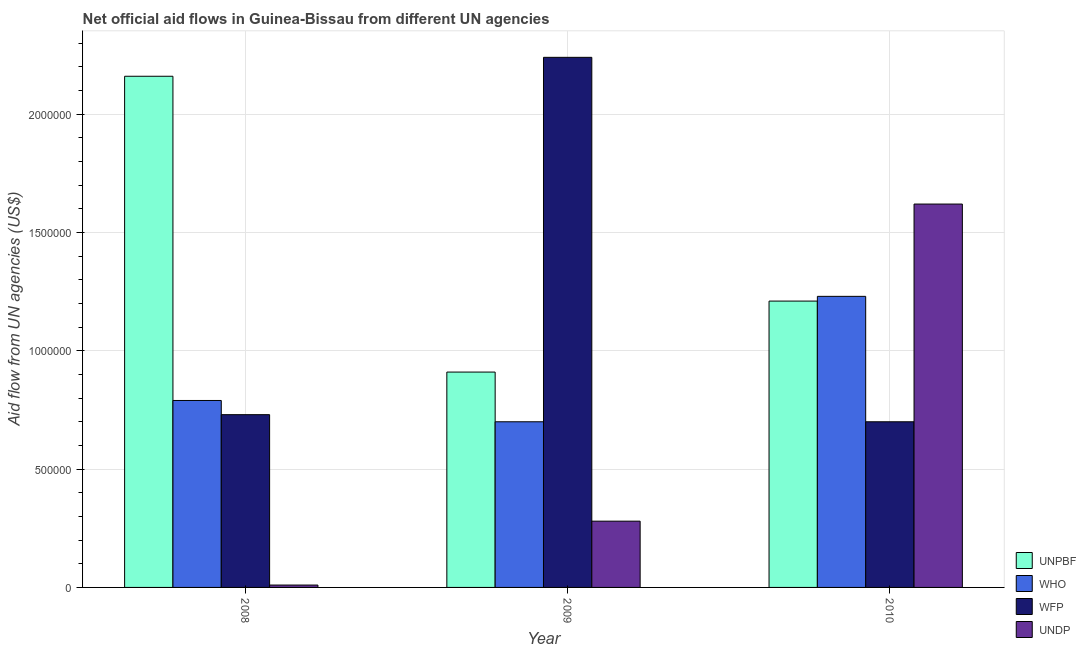How many groups of bars are there?
Offer a very short reply. 3. Are the number of bars per tick equal to the number of legend labels?
Give a very brief answer. Yes. What is the amount of aid given by unpbf in 2008?
Provide a succinct answer. 2.16e+06. Across all years, what is the maximum amount of aid given by wfp?
Ensure brevity in your answer.  2.24e+06. Across all years, what is the minimum amount of aid given by unpbf?
Make the answer very short. 9.10e+05. What is the total amount of aid given by undp in the graph?
Offer a terse response. 1.91e+06. What is the difference between the amount of aid given by wfp in 2008 and that in 2010?
Keep it short and to the point. 3.00e+04. What is the difference between the amount of aid given by undp in 2008 and the amount of aid given by wfp in 2010?
Ensure brevity in your answer.  -1.61e+06. What is the average amount of aid given by unpbf per year?
Ensure brevity in your answer.  1.43e+06. What is the ratio of the amount of aid given by undp in 2008 to that in 2009?
Provide a succinct answer. 0.04. What is the difference between the highest and the second highest amount of aid given by wfp?
Your answer should be very brief. 1.51e+06. What is the difference between the highest and the lowest amount of aid given by wfp?
Offer a very short reply. 1.54e+06. Is it the case that in every year, the sum of the amount of aid given by wfp and amount of aid given by unpbf is greater than the sum of amount of aid given by undp and amount of aid given by who?
Ensure brevity in your answer.  No. What does the 2nd bar from the left in 2009 represents?
Ensure brevity in your answer.  WHO. What does the 2nd bar from the right in 2010 represents?
Offer a very short reply. WFP. Is it the case that in every year, the sum of the amount of aid given by unpbf and amount of aid given by who is greater than the amount of aid given by wfp?
Your response must be concise. No. How many bars are there?
Your response must be concise. 12. How many years are there in the graph?
Your response must be concise. 3. What is the difference between two consecutive major ticks on the Y-axis?
Your answer should be compact. 5.00e+05. Are the values on the major ticks of Y-axis written in scientific E-notation?
Keep it short and to the point. No. Where does the legend appear in the graph?
Provide a succinct answer. Bottom right. How many legend labels are there?
Keep it short and to the point. 4. How are the legend labels stacked?
Offer a terse response. Vertical. What is the title of the graph?
Ensure brevity in your answer.  Net official aid flows in Guinea-Bissau from different UN agencies. What is the label or title of the Y-axis?
Make the answer very short. Aid flow from UN agencies (US$). What is the Aid flow from UN agencies (US$) of UNPBF in 2008?
Your answer should be very brief. 2.16e+06. What is the Aid flow from UN agencies (US$) of WHO in 2008?
Offer a very short reply. 7.90e+05. What is the Aid flow from UN agencies (US$) of WFP in 2008?
Provide a short and direct response. 7.30e+05. What is the Aid flow from UN agencies (US$) in UNDP in 2008?
Offer a terse response. 10000. What is the Aid flow from UN agencies (US$) of UNPBF in 2009?
Ensure brevity in your answer.  9.10e+05. What is the Aid flow from UN agencies (US$) of WHO in 2009?
Give a very brief answer. 7.00e+05. What is the Aid flow from UN agencies (US$) in WFP in 2009?
Provide a short and direct response. 2.24e+06. What is the Aid flow from UN agencies (US$) of UNPBF in 2010?
Your answer should be very brief. 1.21e+06. What is the Aid flow from UN agencies (US$) of WHO in 2010?
Offer a terse response. 1.23e+06. What is the Aid flow from UN agencies (US$) in WFP in 2010?
Give a very brief answer. 7.00e+05. What is the Aid flow from UN agencies (US$) in UNDP in 2010?
Your answer should be very brief. 1.62e+06. Across all years, what is the maximum Aid flow from UN agencies (US$) in UNPBF?
Keep it short and to the point. 2.16e+06. Across all years, what is the maximum Aid flow from UN agencies (US$) of WHO?
Your answer should be very brief. 1.23e+06. Across all years, what is the maximum Aid flow from UN agencies (US$) in WFP?
Provide a short and direct response. 2.24e+06. Across all years, what is the maximum Aid flow from UN agencies (US$) of UNDP?
Ensure brevity in your answer.  1.62e+06. Across all years, what is the minimum Aid flow from UN agencies (US$) in UNPBF?
Provide a succinct answer. 9.10e+05. Across all years, what is the minimum Aid flow from UN agencies (US$) of UNDP?
Provide a succinct answer. 10000. What is the total Aid flow from UN agencies (US$) of UNPBF in the graph?
Make the answer very short. 4.28e+06. What is the total Aid flow from UN agencies (US$) in WHO in the graph?
Offer a very short reply. 2.72e+06. What is the total Aid flow from UN agencies (US$) of WFP in the graph?
Your answer should be very brief. 3.67e+06. What is the total Aid flow from UN agencies (US$) in UNDP in the graph?
Your answer should be compact. 1.91e+06. What is the difference between the Aid flow from UN agencies (US$) of UNPBF in 2008 and that in 2009?
Ensure brevity in your answer.  1.25e+06. What is the difference between the Aid flow from UN agencies (US$) of WHO in 2008 and that in 2009?
Your answer should be compact. 9.00e+04. What is the difference between the Aid flow from UN agencies (US$) in WFP in 2008 and that in 2009?
Your answer should be compact. -1.51e+06. What is the difference between the Aid flow from UN agencies (US$) in UNPBF in 2008 and that in 2010?
Make the answer very short. 9.50e+05. What is the difference between the Aid flow from UN agencies (US$) of WHO in 2008 and that in 2010?
Keep it short and to the point. -4.40e+05. What is the difference between the Aid flow from UN agencies (US$) of UNDP in 2008 and that in 2010?
Your answer should be very brief. -1.61e+06. What is the difference between the Aid flow from UN agencies (US$) in WHO in 2009 and that in 2010?
Your response must be concise. -5.30e+05. What is the difference between the Aid flow from UN agencies (US$) in WFP in 2009 and that in 2010?
Your response must be concise. 1.54e+06. What is the difference between the Aid flow from UN agencies (US$) of UNDP in 2009 and that in 2010?
Provide a succinct answer. -1.34e+06. What is the difference between the Aid flow from UN agencies (US$) in UNPBF in 2008 and the Aid flow from UN agencies (US$) in WHO in 2009?
Your answer should be very brief. 1.46e+06. What is the difference between the Aid flow from UN agencies (US$) of UNPBF in 2008 and the Aid flow from UN agencies (US$) of WFP in 2009?
Give a very brief answer. -8.00e+04. What is the difference between the Aid flow from UN agencies (US$) in UNPBF in 2008 and the Aid flow from UN agencies (US$) in UNDP in 2009?
Provide a short and direct response. 1.88e+06. What is the difference between the Aid flow from UN agencies (US$) of WHO in 2008 and the Aid flow from UN agencies (US$) of WFP in 2009?
Your response must be concise. -1.45e+06. What is the difference between the Aid flow from UN agencies (US$) in WHO in 2008 and the Aid flow from UN agencies (US$) in UNDP in 2009?
Your answer should be very brief. 5.10e+05. What is the difference between the Aid flow from UN agencies (US$) of UNPBF in 2008 and the Aid flow from UN agencies (US$) of WHO in 2010?
Provide a short and direct response. 9.30e+05. What is the difference between the Aid flow from UN agencies (US$) of UNPBF in 2008 and the Aid flow from UN agencies (US$) of WFP in 2010?
Your answer should be very brief. 1.46e+06. What is the difference between the Aid flow from UN agencies (US$) of UNPBF in 2008 and the Aid flow from UN agencies (US$) of UNDP in 2010?
Your response must be concise. 5.40e+05. What is the difference between the Aid flow from UN agencies (US$) of WHO in 2008 and the Aid flow from UN agencies (US$) of WFP in 2010?
Your response must be concise. 9.00e+04. What is the difference between the Aid flow from UN agencies (US$) in WHO in 2008 and the Aid flow from UN agencies (US$) in UNDP in 2010?
Ensure brevity in your answer.  -8.30e+05. What is the difference between the Aid flow from UN agencies (US$) in WFP in 2008 and the Aid flow from UN agencies (US$) in UNDP in 2010?
Give a very brief answer. -8.90e+05. What is the difference between the Aid flow from UN agencies (US$) of UNPBF in 2009 and the Aid flow from UN agencies (US$) of WHO in 2010?
Provide a short and direct response. -3.20e+05. What is the difference between the Aid flow from UN agencies (US$) of UNPBF in 2009 and the Aid flow from UN agencies (US$) of UNDP in 2010?
Ensure brevity in your answer.  -7.10e+05. What is the difference between the Aid flow from UN agencies (US$) of WHO in 2009 and the Aid flow from UN agencies (US$) of UNDP in 2010?
Your answer should be compact. -9.20e+05. What is the difference between the Aid flow from UN agencies (US$) in WFP in 2009 and the Aid flow from UN agencies (US$) in UNDP in 2010?
Your response must be concise. 6.20e+05. What is the average Aid flow from UN agencies (US$) of UNPBF per year?
Keep it short and to the point. 1.43e+06. What is the average Aid flow from UN agencies (US$) of WHO per year?
Provide a succinct answer. 9.07e+05. What is the average Aid flow from UN agencies (US$) of WFP per year?
Your answer should be compact. 1.22e+06. What is the average Aid flow from UN agencies (US$) in UNDP per year?
Provide a succinct answer. 6.37e+05. In the year 2008, what is the difference between the Aid flow from UN agencies (US$) of UNPBF and Aid flow from UN agencies (US$) of WHO?
Provide a short and direct response. 1.37e+06. In the year 2008, what is the difference between the Aid flow from UN agencies (US$) of UNPBF and Aid flow from UN agencies (US$) of WFP?
Offer a very short reply. 1.43e+06. In the year 2008, what is the difference between the Aid flow from UN agencies (US$) of UNPBF and Aid flow from UN agencies (US$) of UNDP?
Your response must be concise. 2.15e+06. In the year 2008, what is the difference between the Aid flow from UN agencies (US$) of WHO and Aid flow from UN agencies (US$) of UNDP?
Give a very brief answer. 7.80e+05. In the year 2008, what is the difference between the Aid flow from UN agencies (US$) of WFP and Aid flow from UN agencies (US$) of UNDP?
Offer a terse response. 7.20e+05. In the year 2009, what is the difference between the Aid flow from UN agencies (US$) in UNPBF and Aid flow from UN agencies (US$) in WFP?
Make the answer very short. -1.33e+06. In the year 2009, what is the difference between the Aid flow from UN agencies (US$) in UNPBF and Aid flow from UN agencies (US$) in UNDP?
Your answer should be compact. 6.30e+05. In the year 2009, what is the difference between the Aid flow from UN agencies (US$) in WHO and Aid flow from UN agencies (US$) in WFP?
Make the answer very short. -1.54e+06. In the year 2009, what is the difference between the Aid flow from UN agencies (US$) of WHO and Aid flow from UN agencies (US$) of UNDP?
Keep it short and to the point. 4.20e+05. In the year 2009, what is the difference between the Aid flow from UN agencies (US$) in WFP and Aid flow from UN agencies (US$) in UNDP?
Ensure brevity in your answer.  1.96e+06. In the year 2010, what is the difference between the Aid flow from UN agencies (US$) of UNPBF and Aid flow from UN agencies (US$) of WFP?
Offer a terse response. 5.10e+05. In the year 2010, what is the difference between the Aid flow from UN agencies (US$) in UNPBF and Aid flow from UN agencies (US$) in UNDP?
Your response must be concise. -4.10e+05. In the year 2010, what is the difference between the Aid flow from UN agencies (US$) in WHO and Aid flow from UN agencies (US$) in WFP?
Give a very brief answer. 5.30e+05. In the year 2010, what is the difference between the Aid flow from UN agencies (US$) in WHO and Aid flow from UN agencies (US$) in UNDP?
Your response must be concise. -3.90e+05. In the year 2010, what is the difference between the Aid flow from UN agencies (US$) in WFP and Aid flow from UN agencies (US$) in UNDP?
Make the answer very short. -9.20e+05. What is the ratio of the Aid flow from UN agencies (US$) in UNPBF in 2008 to that in 2009?
Offer a terse response. 2.37. What is the ratio of the Aid flow from UN agencies (US$) of WHO in 2008 to that in 2009?
Give a very brief answer. 1.13. What is the ratio of the Aid flow from UN agencies (US$) of WFP in 2008 to that in 2009?
Make the answer very short. 0.33. What is the ratio of the Aid flow from UN agencies (US$) in UNDP in 2008 to that in 2009?
Provide a succinct answer. 0.04. What is the ratio of the Aid flow from UN agencies (US$) in UNPBF in 2008 to that in 2010?
Give a very brief answer. 1.79. What is the ratio of the Aid flow from UN agencies (US$) of WHO in 2008 to that in 2010?
Give a very brief answer. 0.64. What is the ratio of the Aid flow from UN agencies (US$) in WFP in 2008 to that in 2010?
Make the answer very short. 1.04. What is the ratio of the Aid flow from UN agencies (US$) in UNDP in 2008 to that in 2010?
Offer a very short reply. 0.01. What is the ratio of the Aid flow from UN agencies (US$) in UNPBF in 2009 to that in 2010?
Offer a very short reply. 0.75. What is the ratio of the Aid flow from UN agencies (US$) of WHO in 2009 to that in 2010?
Provide a succinct answer. 0.57. What is the ratio of the Aid flow from UN agencies (US$) of WFP in 2009 to that in 2010?
Give a very brief answer. 3.2. What is the ratio of the Aid flow from UN agencies (US$) of UNDP in 2009 to that in 2010?
Make the answer very short. 0.17. What is the difference between the highest and the second highest Aid flow from UN agencies (US$) in UNPBF?
Provide a succinct answer. 9.50e+05. What is the difference between the highest and the second highest Aid flow from UN agencies (US$) in WFP?
Your answer should be very brief. 1.51e+06. What is the difference between the highest and the second highest Aid flow from UN agencies (US$) of UNDP?
Your response must be concise. 1.34e+06. What is the difference between the highest and the lowest Aid flow from UN agencies (US$) of UNPBF?
Offer a very short reply. 1.25e+06. What is the difference between the highest and the lowest Aid flow from UN agencies (US$) in WHO?
Keep it short and to the point. 5.30e+05. What is the difference between the highest and the lowest Aid flow from UN agencies (US$) of WFP?
Provide a succinct answer. 1.54e+06. What is the difference between the highest and the lowest Aid flow from UN agencies (US$) in UNDP?
Your response must be concise. 1.61e+06. 